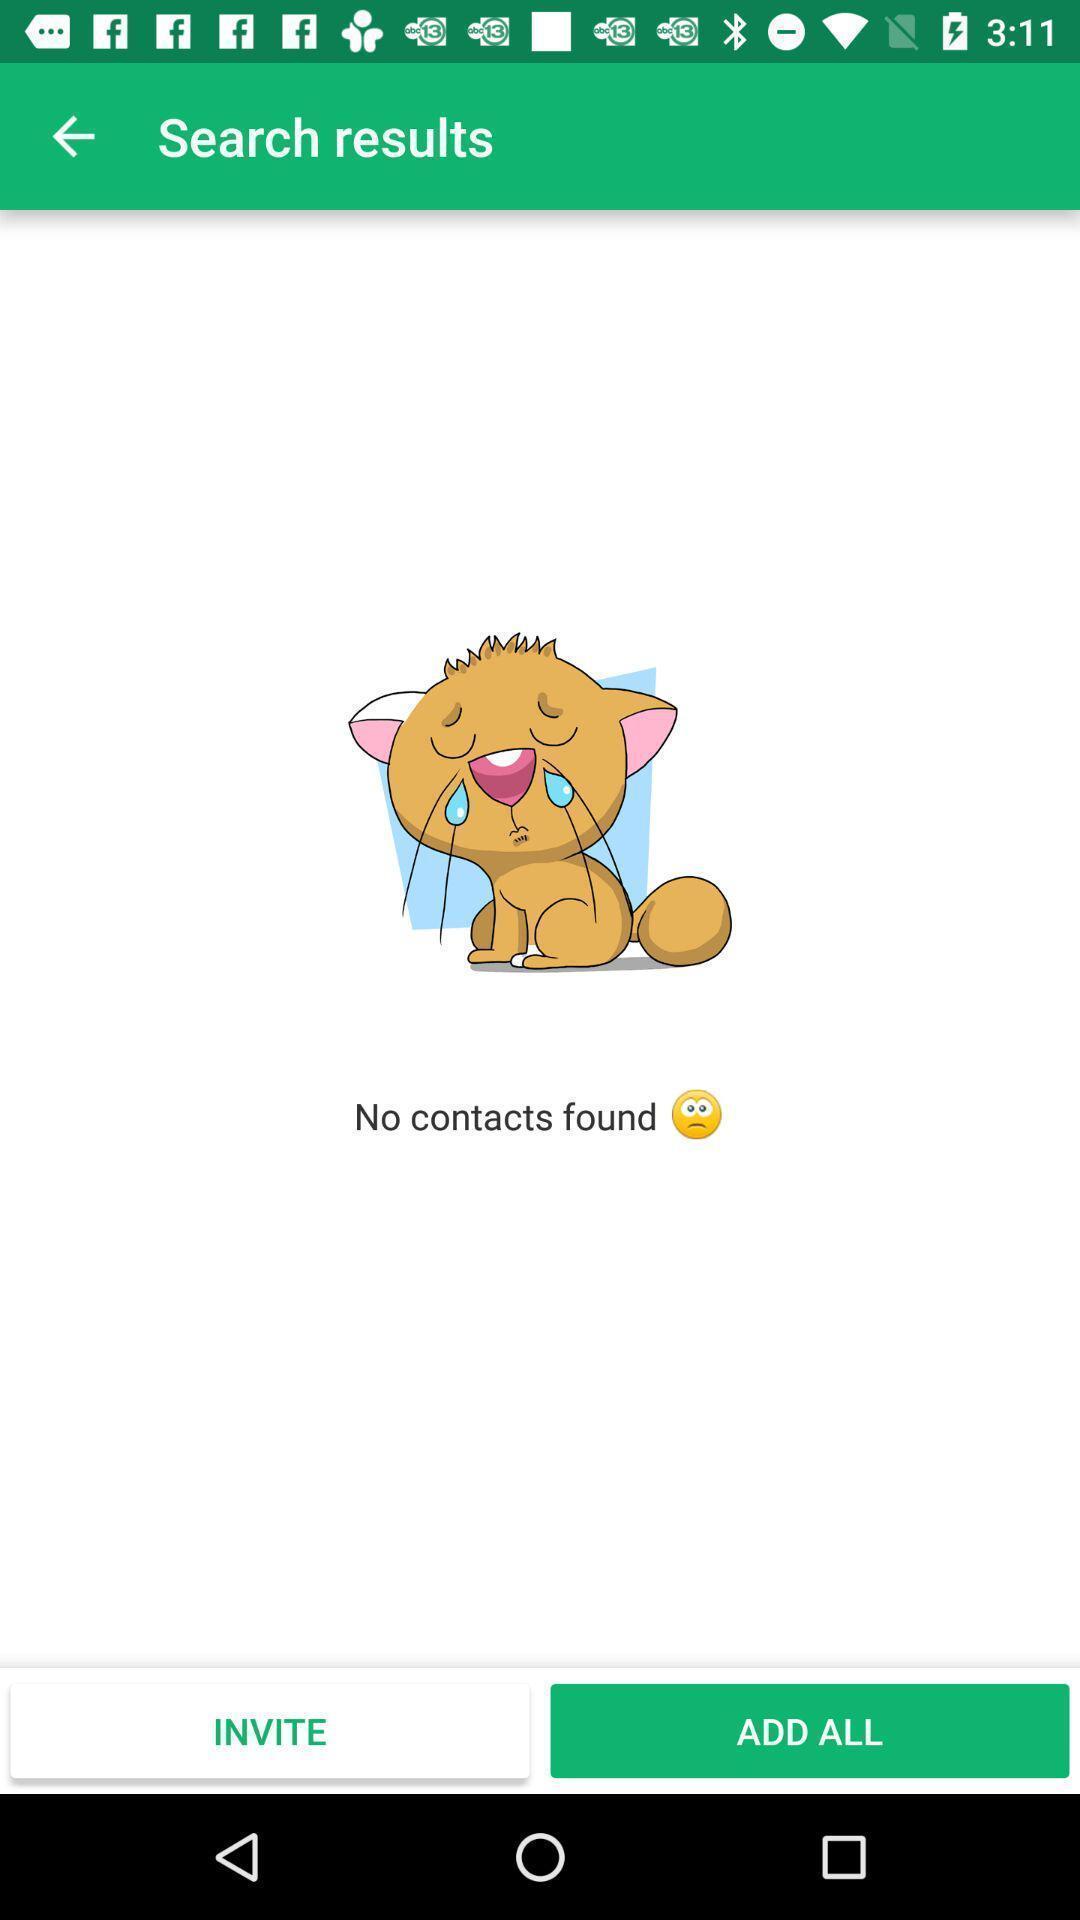Provide a description of this screenshot. Page showing search results. 